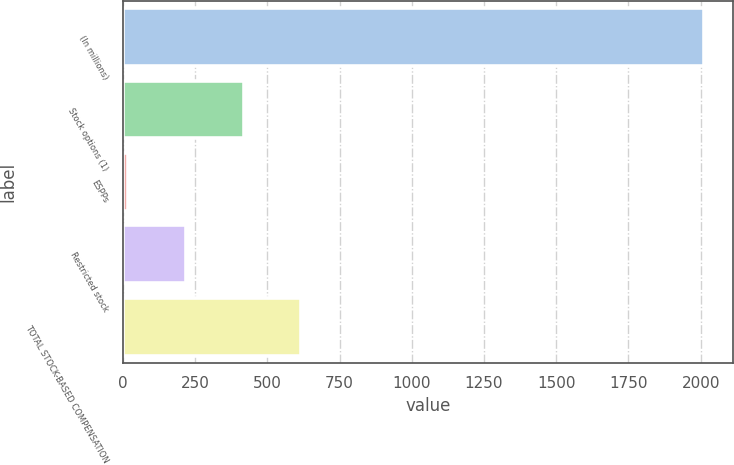Convert chart. <chart><loc_0><loc_0><loc_500><loc_500><bar_chart><fcel>(In millions)<fcel>Stock options (1)<fcel>ESPPs<fcel>Restricted stock<fcel>TOTAL STOCK-BASED COMPENSATION<nl><fcel>2013<fcel>417.8<fcel>19<fcel>218.4<fcel>617.2<nl></chart> 